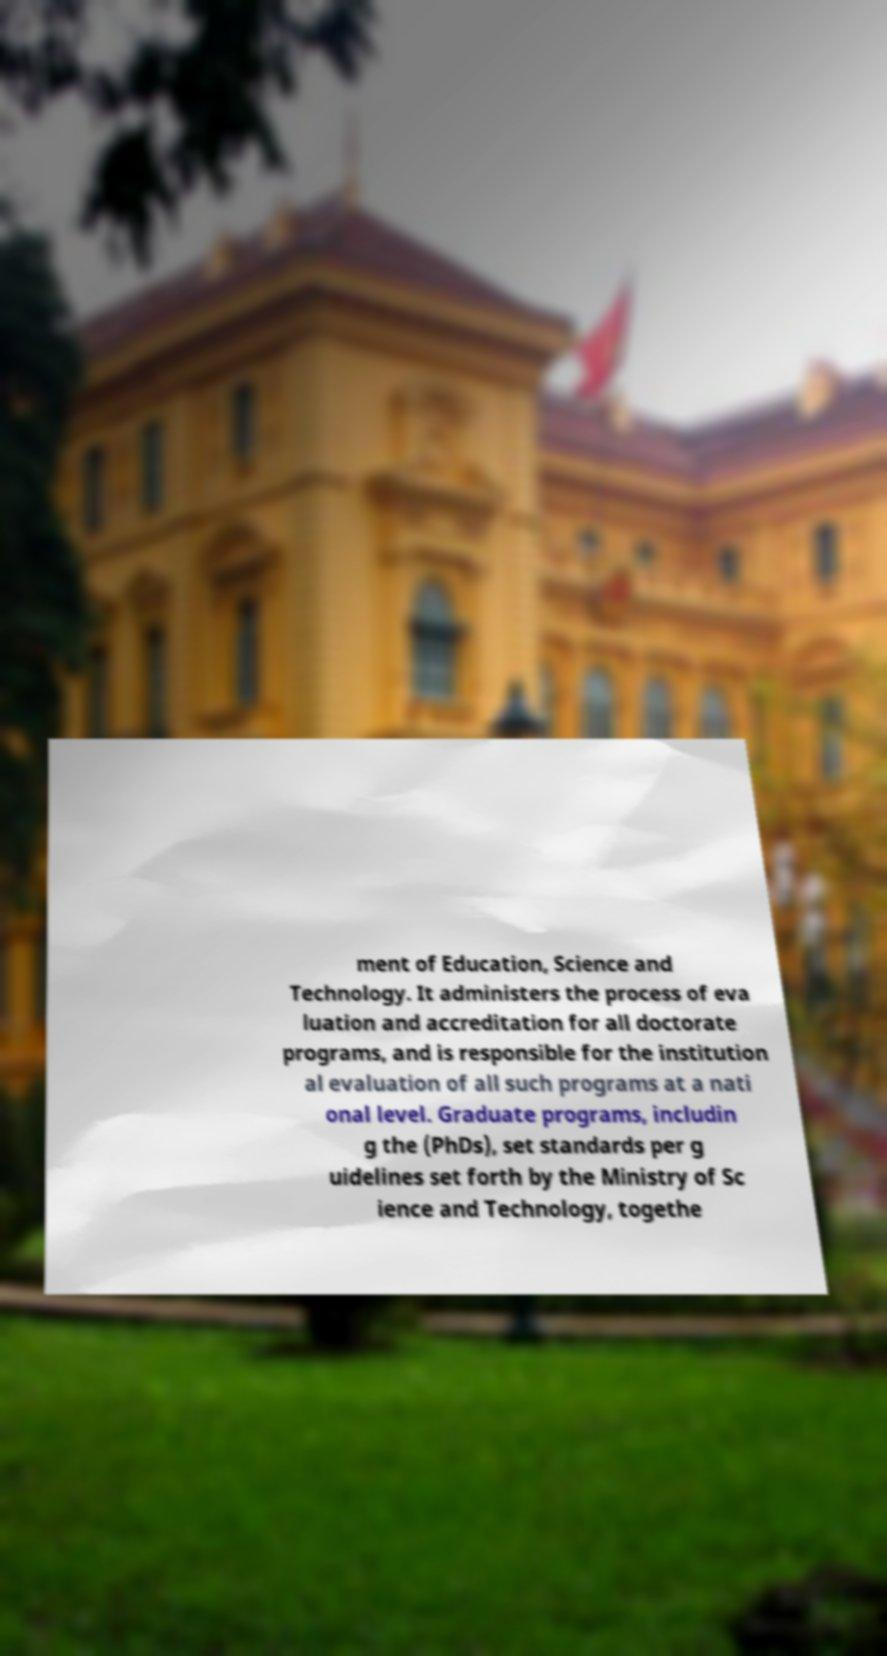What messages or text are displayed in this image? I need them in a readable, typed format. ment of Education, Science and Technology. It administers the process of eva luation and accreditation for all doctorate programs, and is responsible for the institution al evaluation of all such programs at a nati onal level. Graduate programs, includin g the (PhDs), set standards per g uidelines set forth by the Ministry of Sc ience and Technology, togethe 